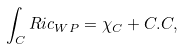<formula> <loc_0><loc_0><loc_500><loc_500>\int _ { C } { R i c _ { W P } } = \chi _ { C } + C . C ,</formula> 